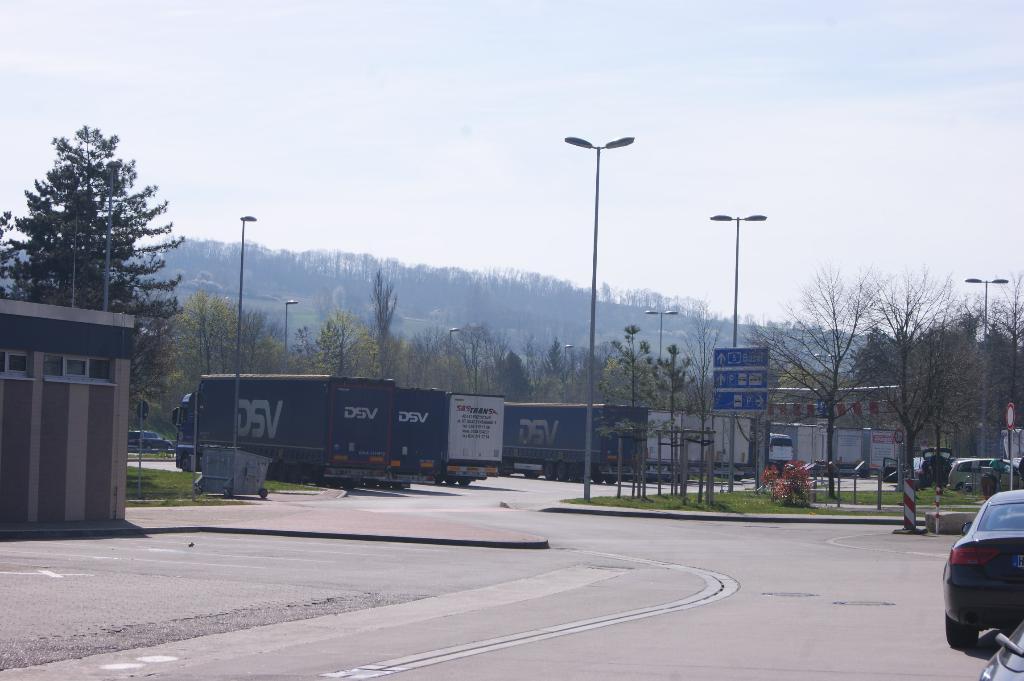How would you summarize this image in a sentence or two? In this image I can see a road in the centre and on the both side of it I can see number of vehicles, number of poles, street lights, few sign boards and on these boards I can see something is written. In the background I can see clouds, the sky and on the left side of this image I can see a building. 